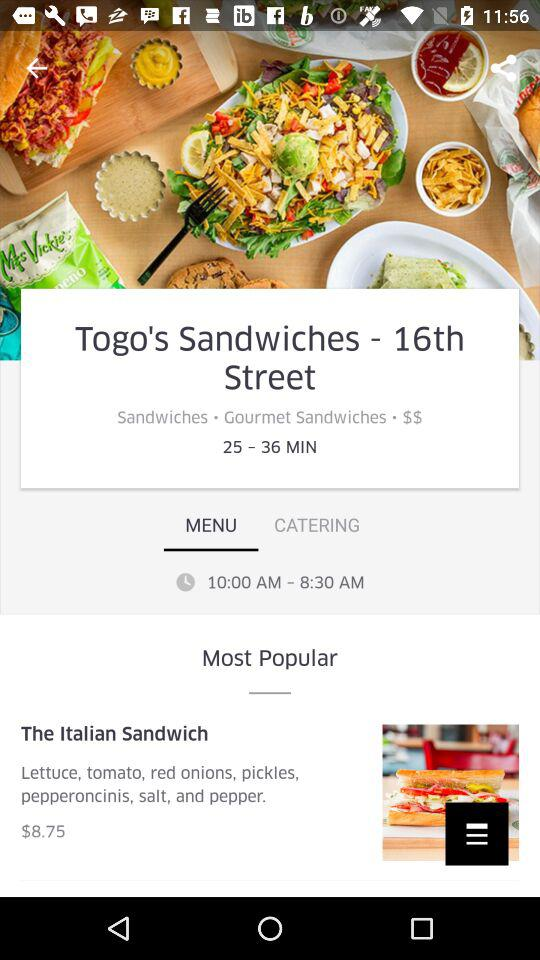What is the selected date?
When the provided information is insufficient, respond with <no answer>. <no answer> 